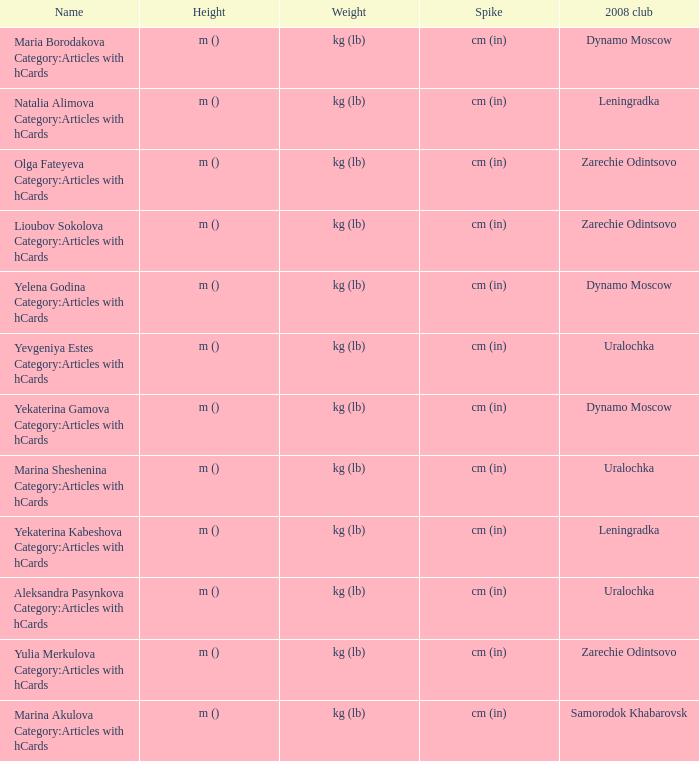In 2008, what was the club called zarechie odintsovo named? Olga Fateyeva Category:Articles with hCards, Lioubov Sokolova Category:Articles with hCards, Yulia Merkulova Category:Articles with hCards. 